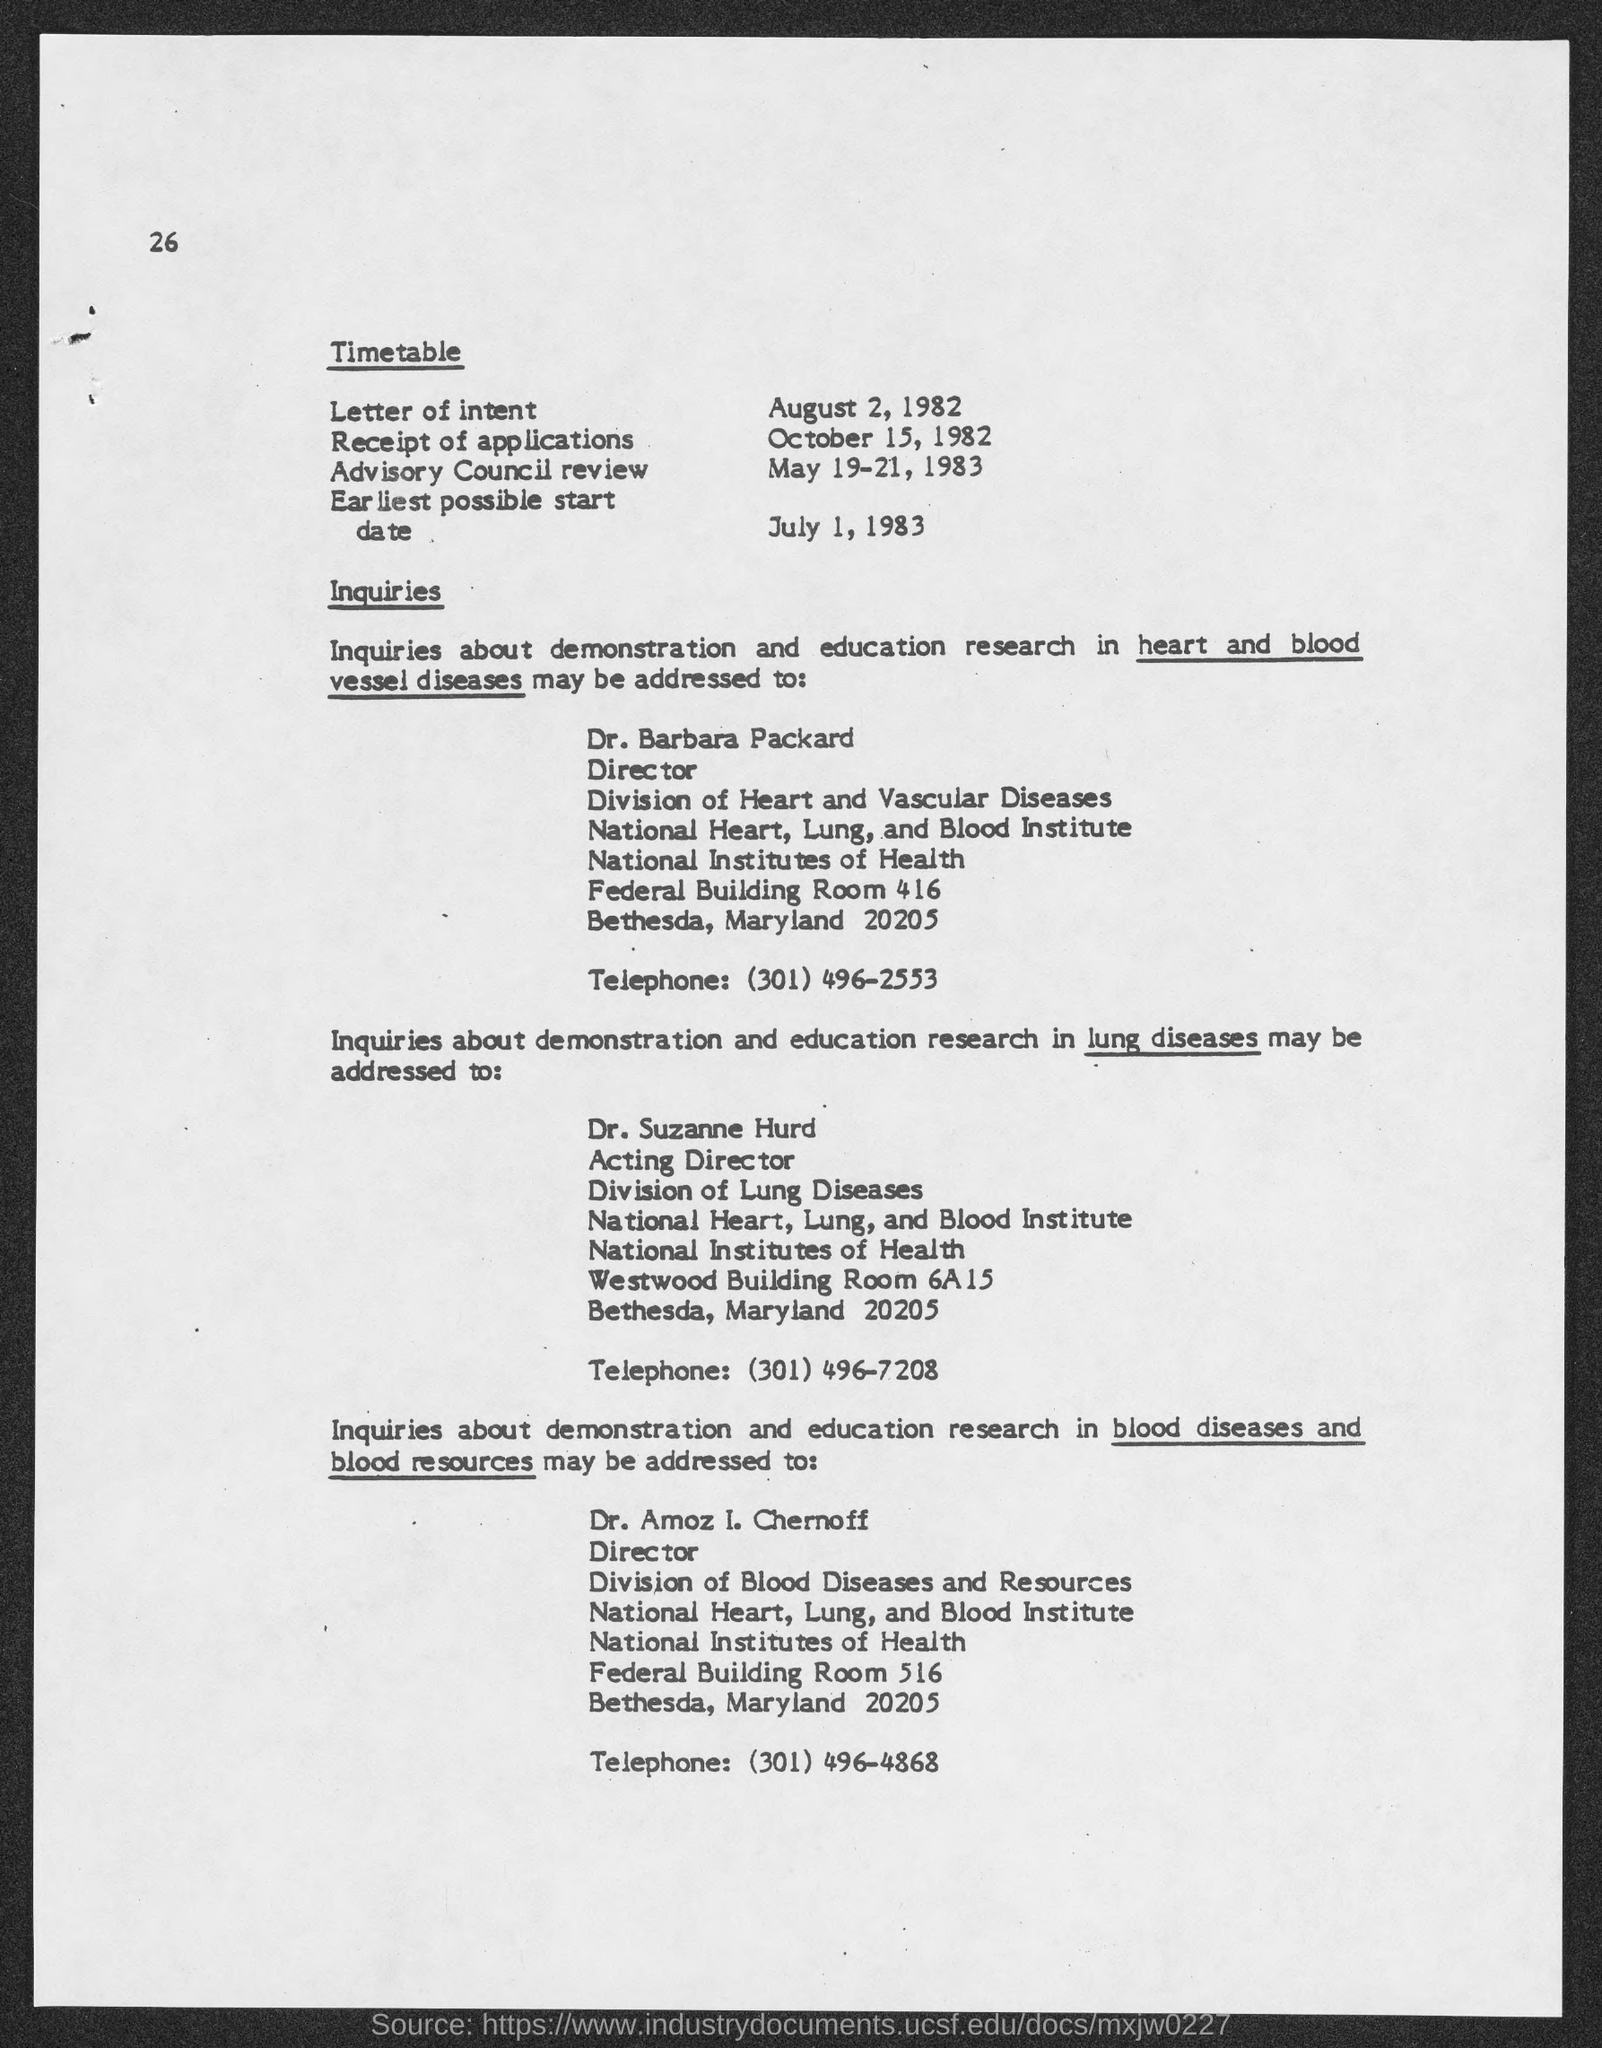Draw attention to some important aspects in this diagram. Inquiries about demonstration and education research in heart and blood vessel diseases should be directed to Dr. Barbara Packard. Inquiries regarding demonstration and education research in lung diseases should be directed to Dr. Suzanne Hurd. Dr. Amoz I. Chernoff holds the position of director. Barbara Packard holds the position of Director. The telephone number of Dr. Suzanne Hurd is (301) 496-7208. 